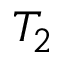<formula> <loc_0><loc_0><loc_500><loc_500>T _ { 2 }</formula> 